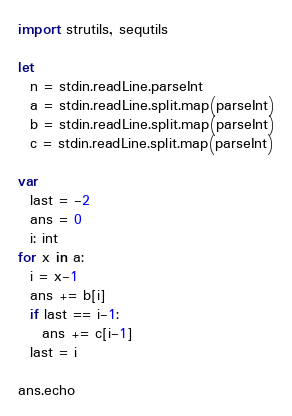Convert code to text. <code><loc_0><loc_0><loc_500><loc_500><_Nim_>import strutils, sequtils

let
  n = stdin.readLine.parseInt
  a = stdin.readLine.split.map(parseInt)
  b = stdin.readLine.split.map(parseInt)
  c = stdin.readLine.split.map(parseInt)

var
  last = -2
  ans = 0
  i: int
for x in a:
  i = x-1
  ans += b[i]
  if last == i-1:
    ans += c[i-1]
  last = i

ans.echo
</code> 